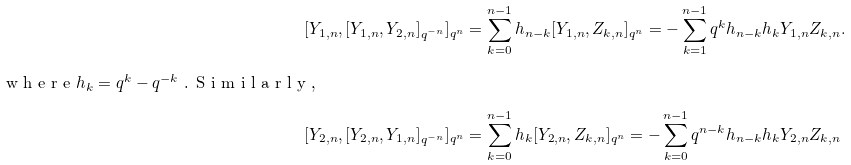Convert formula to latex. <formula><loc_0><loc_0><loc_500><loc_500>[ Y _ { 1 , n } , [ Y _ { 1 , n } , Y _ { 2 , n } ] _ { q ^ { - n } } ] _ { q ^ { n } } & = \sum _ { k = 0 } ^ { n - 1 } h _ { n - k } [ Y _ { 1 , n } , Z _ { k , n } ] _ { q ^ { n } } = - \sum _ { k = 1 } ^ { n - 1 } q ^ { k } h _ { n - k } h _ { k } Y _ { 1 , n } Z _ { k , n } . \\ \intertext { w h e r e $ h _ { k } = q ^ { k } - q ^ { - k } $ . S i m i l a r l y , } [ Y _ { 2 , n } , [ Y _ { 2 , n } , Y _ { 1 , n } ] _ { q ^ { - n } } ] _ { q ^ { n } } & = \sum _ { k = 0 } ^ { n - 1 } h _ { k } [ Y _ { 2 , n } , Z _ { k , n } ] _ { q ^ { n } } = - \sum _ { k = 0 } ^ { n - 1 } q ^ { n - k } h _ { n - k } h _ { k } Y _ { 2 , n } Z _ { k , n }</formula> 